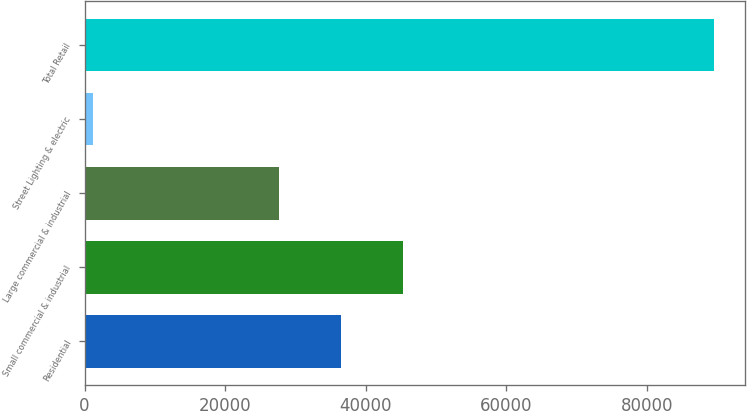Convert chart. <chart><loc_0><loc_0><loc_500><loc_500><bar_chart><fcel>Residential<fcel>Small commercial & industrial<fcel>Large commercial & industrial<fcel>Street Lighting & electric<fcel>Total Retail<nl><fcel>36560.6<fcel>45389.2<fcel>27732<fcel>1235<fcel>89521<nl></chart> 